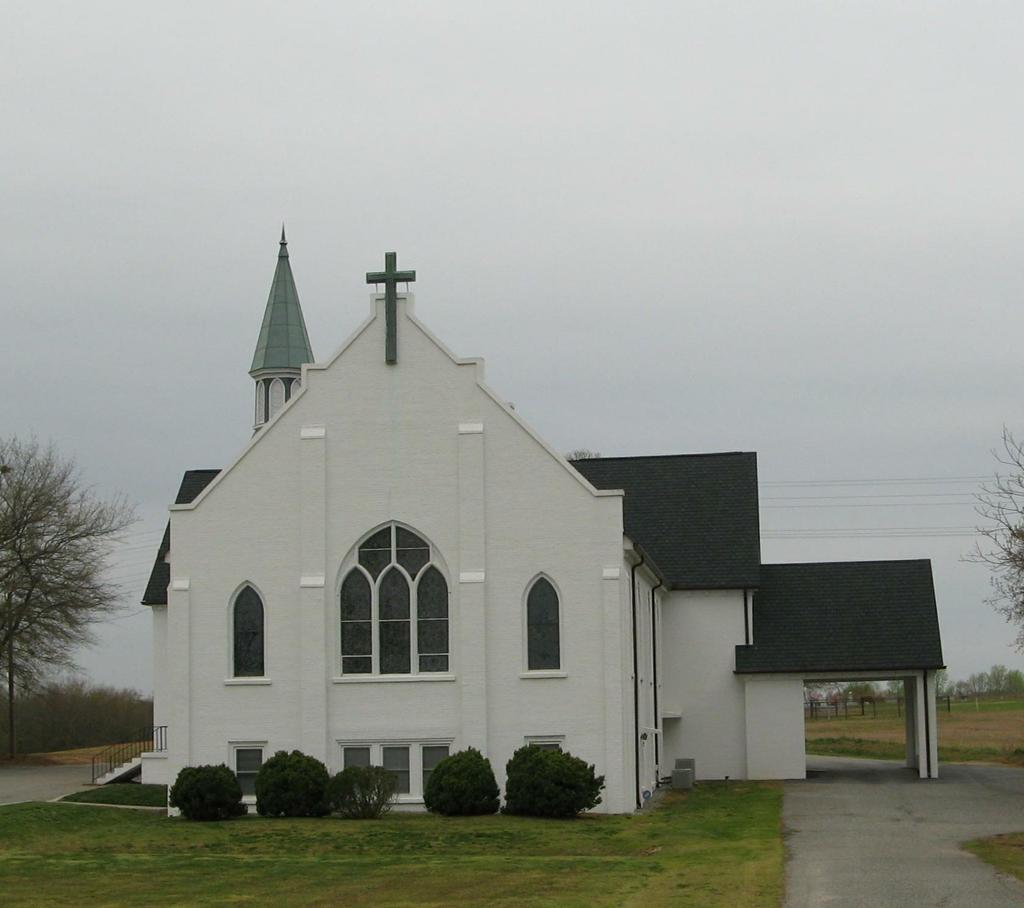What type of vegetation is present on the ground in the image? There is grass and plants on the ground in the image. What type of structure is visible in the image? There is a building in the image. What features can be observed on the building? The building has windows and a roof. What can be seen in the background of the image? There are trees, grass, electric wires, and clouds in the sky in the background of the image. What type of hat is the building wearing in the image? Buildings do not wear hats; the question is not applicable to the image. What activity is taking place in the image? The image does not depict any specific activity; it shows a building, vegetation, and background elements. 